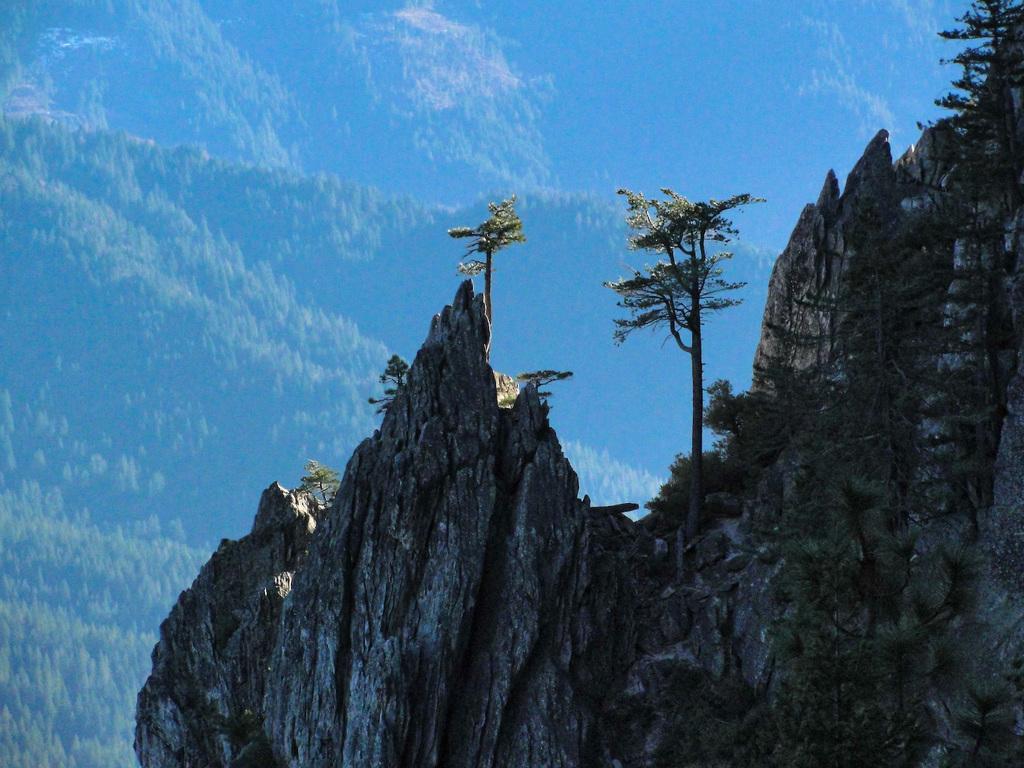Please provide a concise description of this image. In this image we can see a mountain, on the mountain there are some trees, in the background we can see the sky. 